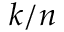Convert formula to latex. <formula><loc_0><loc_0><loc_500><loc_500>k / n</formula> 